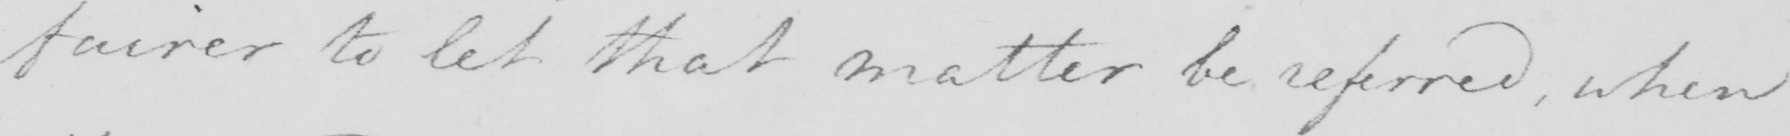What is written in this line of handwriting? fairer to let that matter be referred , when 